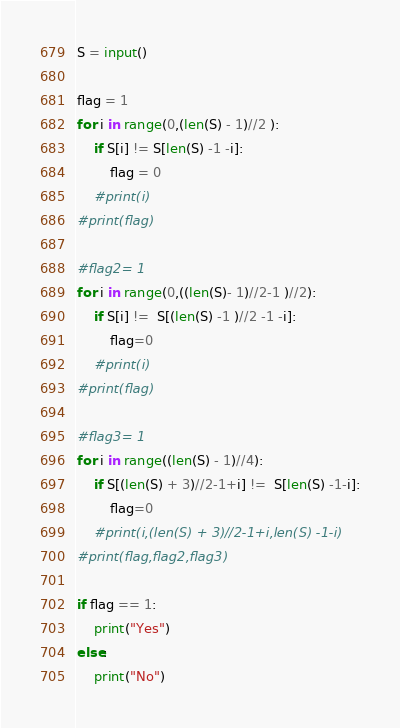<code> <loc_0><loc_0><loc_500><loc_500><_Python_>S = input()

flag = 1
for i in range(0,(len(S) - 1)//2 ):
	if S[i] != S[len(S) -1 -i]:
		flag = 0
	#print(i)
#print(flag)

#flag2= 1
for i in range(0,((len(S)- 1)//2-1 )//2):
	if S[i] !=  S[(len(S) -1 )//2 -1 -i]:
		flag=0
	#print(i)
#print(flag)

#flag3= 1
for i in range((len(S) - 1)//4):
	if S[(len(S) + 3)//2-1+i] !=  S[len(S) -1-i]:
		flag=0
	#print(i,(len(S) + 3)//2-1+i,len(S) -1-i)
#print(flag,flag2,flag3)

if flag == 1:
	print("Yes")
else:
	print("No")</code> 